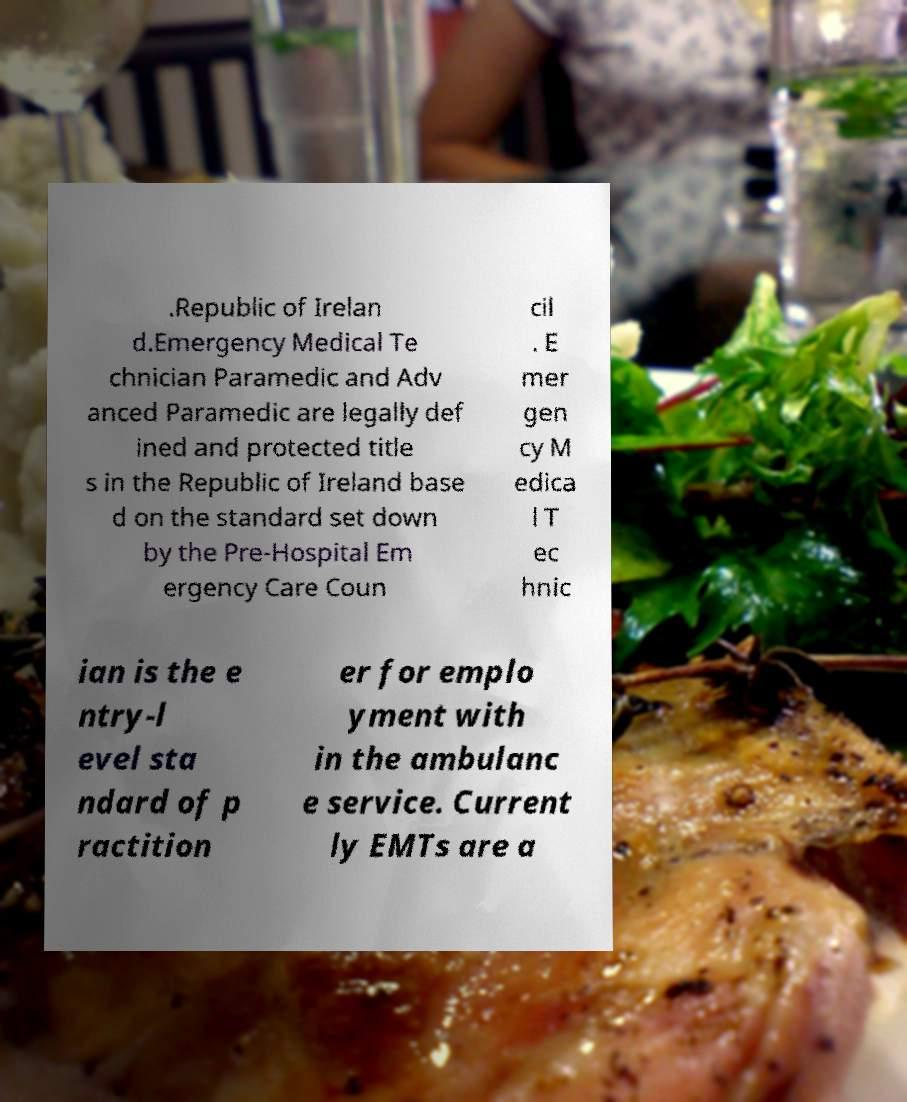Please read and relay the text visible in this image. What does it say? .Republic of Irelan d.Emergency Medical Te chnician Paramedic and Adv anced Paramedic are legally def ined and protected title s in the Republic of Ireland base d on the standard set down by the Pre-Hospital Em ergency Care Coun cil . E mer gen cy M edica l T ec hnic ian is the e ntry-l evel sta ndard of p ractition er for emplo yment with in the ambulanc e service. Current ly EMTs are a 